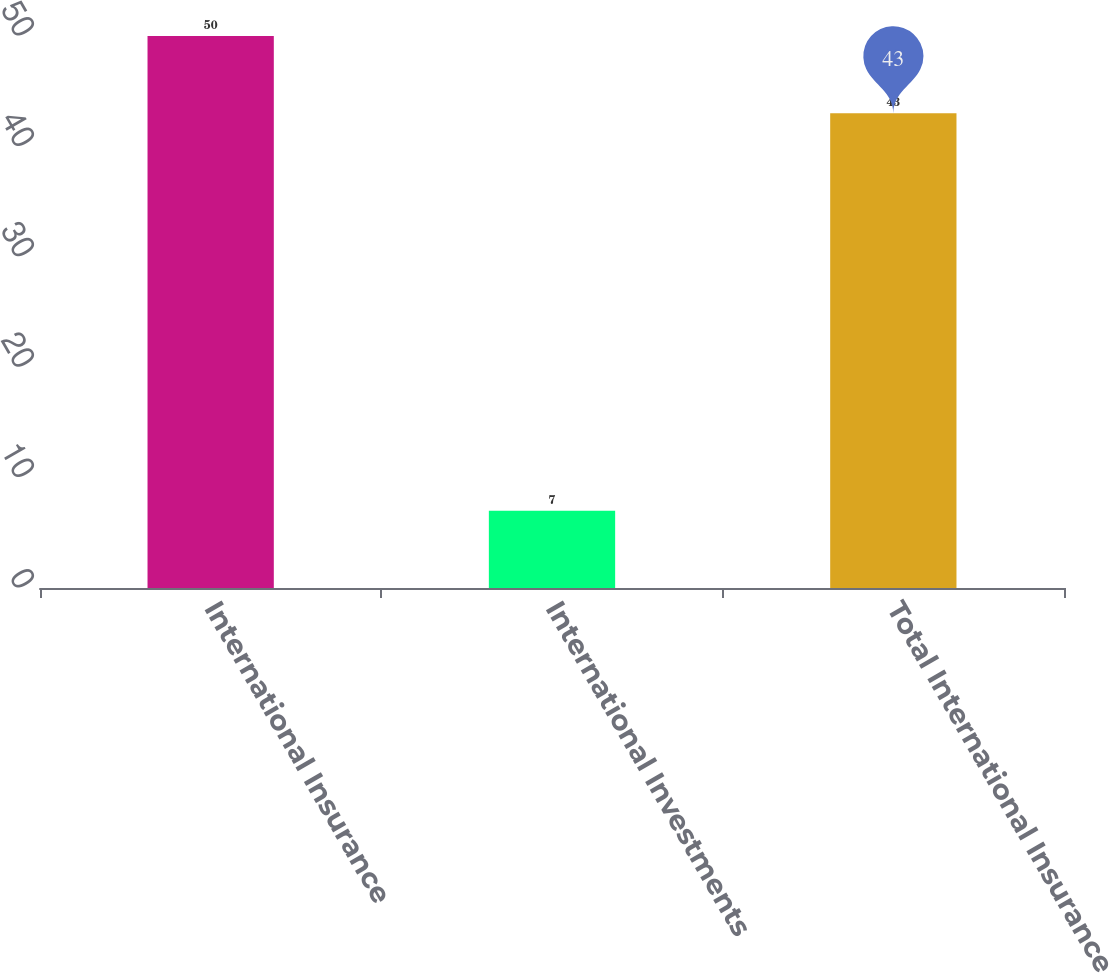Convert chart to OTSL. <chart><loc_0><loc_0><loc_500><loc_500><bar_chart><fcel>International Insurance<fcel>International Investments<fcel>Total International Insurance<nl><fcel>50<fcel>7<fcel>43<nl></chart> 